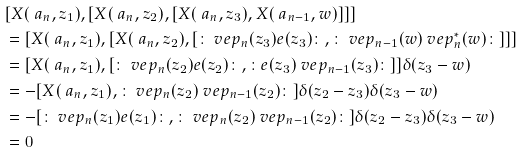<formula> <loc_0><loc_0><loc_500><loc_500>& [ X ( \ a _ { n } , z _ { 1 } ) , [ X ( \ a _ { n } , z _ { 2 } ) , [ X ( \ a _ { n } , z _ { 3 } ) , X ( \ a _ { n - 1 } , w ) ] ] ] \\ & = [ X ( \ a _ { n } , z _ { 1 } ) , [ X ( \ a _ { n } , z _ { 2 } ) , [ \colon \ v e p _ { n } ( z _ { 3 } ) e ( z _ { 3 } ) \colon , \colon \ v e p _ { n - 1 } ( w ) \ v e p _ { n } ^ { * } ( w ) \colon ] ] ] \\ & = [ X ( \ a _ { n } , z _ { 1 } ) , [ \colon \ v e p _ { n } ( z _ { 2 } ) e ( z _ { 2 } ) \colon , \colon e ( z _ { 3 } ) \ v e p _ { n - 1 } ( z _ { 3 } ) \colon ] ] \delta ( z _ { 3 } - w ) \\ & = - [ X ( \ a _ { n } , z _ { 1 } ) , \colon \ v e p _ { n } ( z _ { 2 } ) \ v e p _ { n - 1 } ( z _ { 2 } ) \colon ] \delta ( z _ { 2 } - z _ { 3 } ) \delta ( z _ { 3 } - w ) \\ & = - [ \colon \ v e p _ { n } ( z _ { 1 } ) e ( z _ { 1 } ) \colon , \colon \ v e p _ { n } ( z _ { 2 } ) \ v e p _ { n - 1 } ( z _ { 2 } ) \colon ] \delta ( z _ { 2 } - z _ { 3 } ) \delta ( z _ { 3 } - w ) \\ & = 0</formula> 